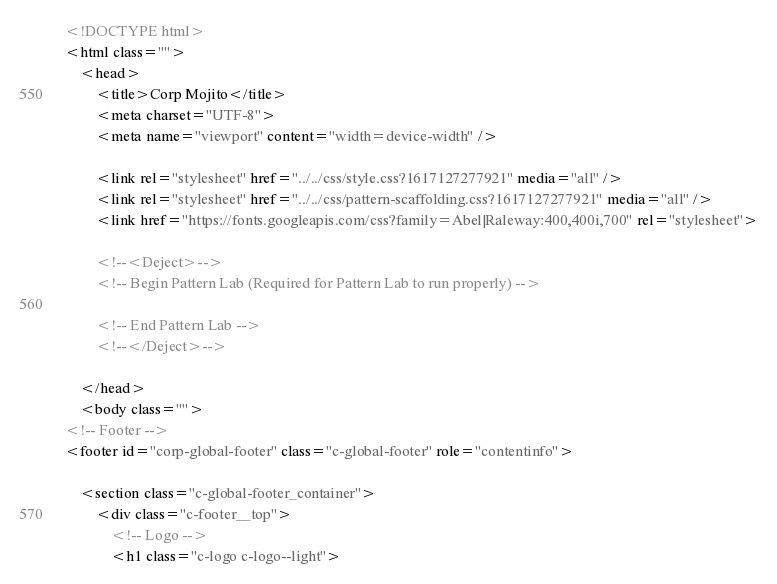Convert code to text. <code><loc_0><loc_0><loc_500><loc_500><_HTML_><!DOCTYPE html>
<html class="">
	<head>
		<title>Corp Mojito</title>
		<meta charset="UTF-8">
		<meta name="viewport" content="width=device-width" />

		<link rel="stylesheet" href="../../css/style.css?1617127277921" media="all" />
		<link rel="stylesheet" href="../../css/pattern-scaffolding.css?1617127277921" media="all" />
		<link href="https://fonts.googleapis.com/css?family=Abel|Raleway:400,400i,700" rel="stylesheet">

		<!--<Deject>-->
		<!-- Begin Pattern Lab (Required for Pattern Lab to run properly) -->
		
		<!-- End Pattern Lab -->
		<!--</Deject>-->

	</head>
	<body class="">
<!-- Footer -->
<footer id="corp-global-footer" class="c-global-footer" role="contentinfo">

    <section class="c-global-footer_container">
		<div class="c-footer__top">
			<!-- Logo -->
			<h1 class="c-logo c-logo--light"></code> 